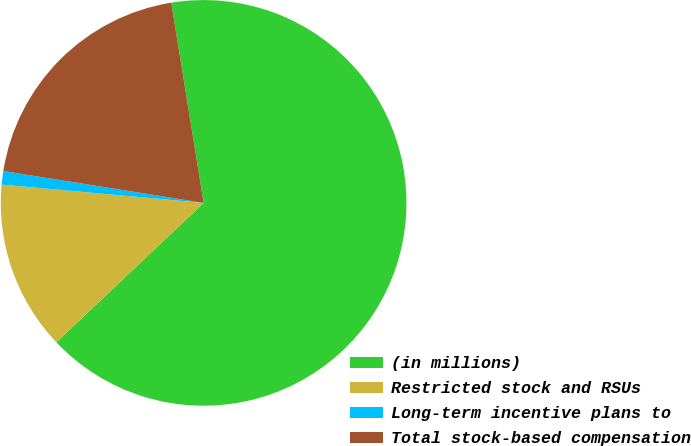<chart> <loc_0><loc_0><loc_500><loc_500><pie_chart><fcel>(in millions)<fcel>Restricted stock and RSUs<fcel>Long-term incentive plans to<fcel>Total stock-based compensation<nl><fcel>65.48%<fcel>13.5%<fcel>1.07%<fcel>19.94%<nl></chart> 